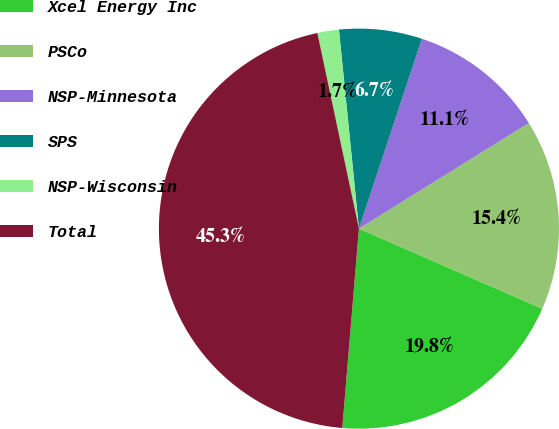Convert chart to OTSL. <chart><loc_0><loc_0><loc_500><loc_500><pie_chart><fcel>Xcel Energy Inc<fcel>PSCo<fcel>NSP-Minnesota<fcel>SPS<fcel>NSP-Wisconsin<fcel>Total<nl><fcel>19.77%<fcel>15.41%<fcel>11.05%<fcel>6.69%<fcel>1.74%<fcel>45.34%<nl></chart> 